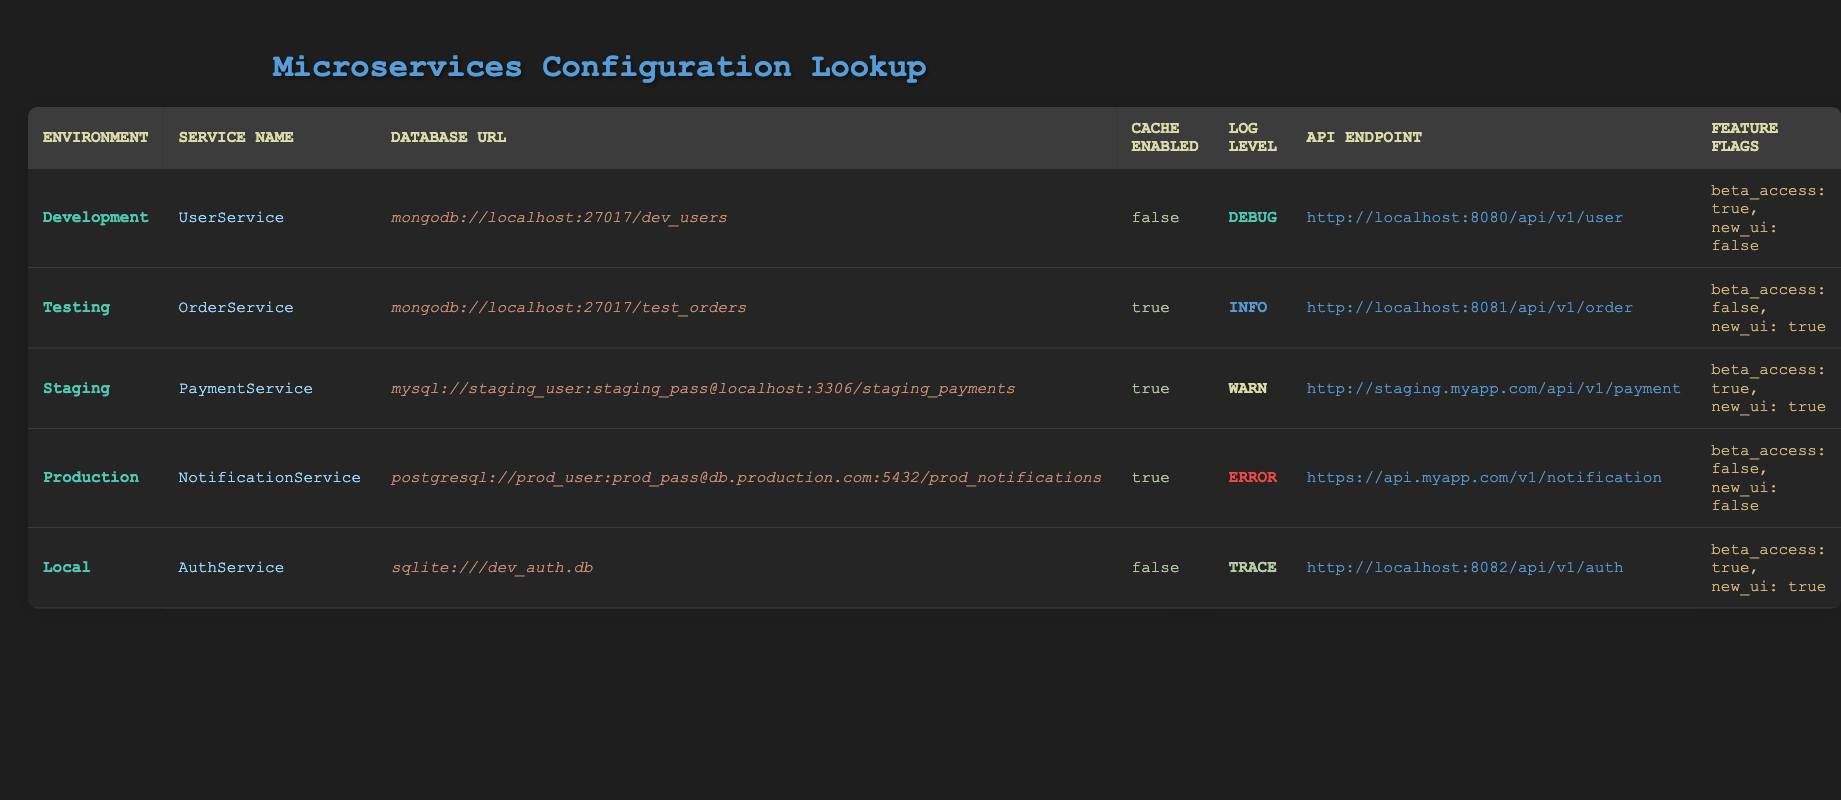What database is used in the Production environment? The table indicates that in the Production environment, the database URL is "postgresql://prod_user:prod_pass@db.production.com:5432/prod_notifications", which specifies that PostgreSQL is the database being used.
Answer: PostgreSQL Is caching enabled for the OrderService? According to the table, the "cache_enabled" value for the OrderService (in the Testing environment) is "true".
Answer: Yes What is the log level for the UserService? By examining the table, we can see that the "log_level" for the UserService (in the Development environment) is "debug".
Answer: Debug How many services have caching disabled? The table shows that the services with caching disabled are UserService in Development and AuthService in Local, totaling two services with caching disabled.
Answer: 2 Is the new UI feature flag enabled in the Staging environment? Reviewing the feature flags for the PaymentService in the Staging environment, we find that the "new_ui" flag is set to true.
Answer: Yes What is the API endpoint for the AuthService? The table shows that the API endpoint for the AuthService (in the Local environment) is "http://localhost:8082/api/v1/auth".
Answer: http://localhost:8082/api/v1/auth What are the feature flags for the NotificationService in Production? By looking at the table, we see that the feature flags for the NotificationService in the Production environment are "beta_access: false, new_ui: false".
Answer: beta_access: false, new_ui: false Which service has the highest log level? To determine the service with the highest log level, we examine the log levels: debug, info, warn, error, and trace. The highest level (most severe) is "error", which applies to the NotificationService in Production. Thus, the NotificationService holds the highest log level.
Answer: NotificationService In which environment is the cache enabled for the UserService? The table shows that the UserService in the Development environment has the cache disabled (cache_enabled: false), confirming that cache is not enabled for this service in any environment.
Answer: No environment has cache enabled for UserService 